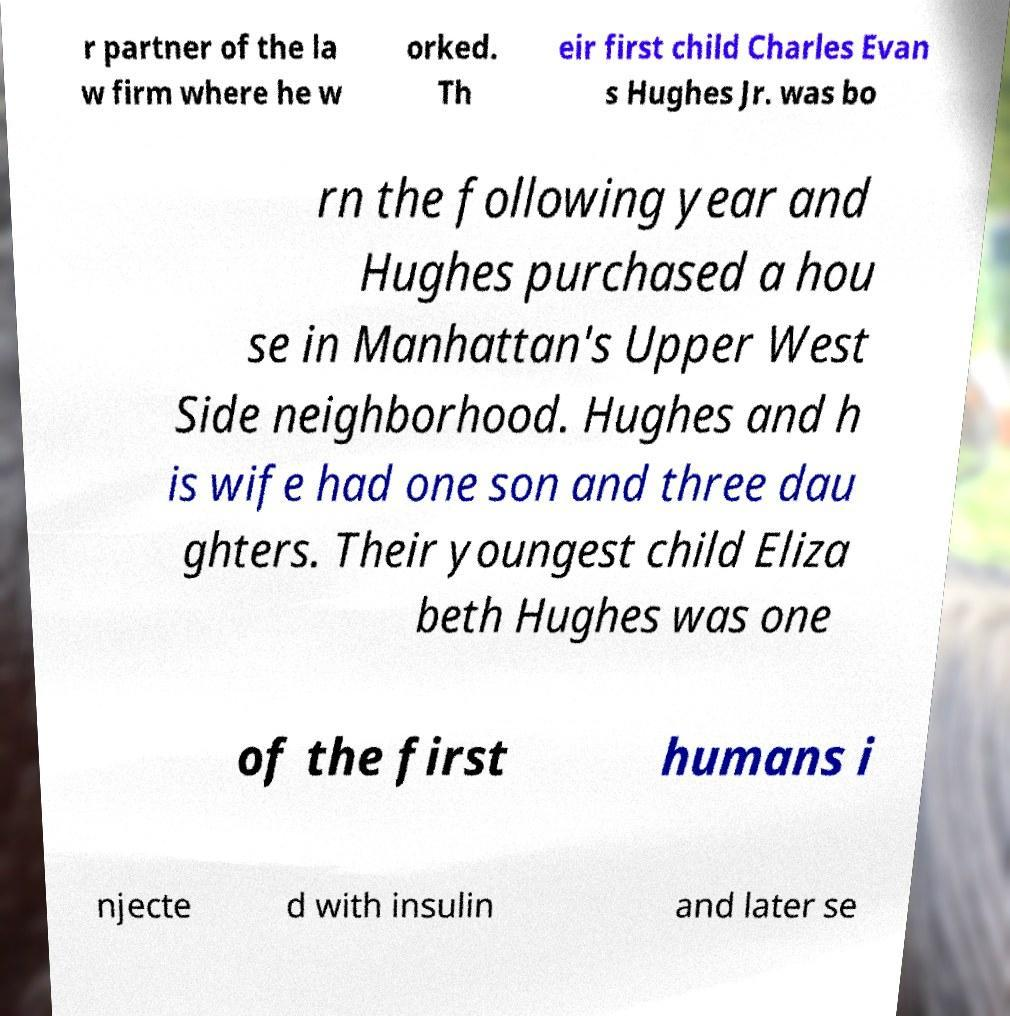Could you assist in decoding the text presented in this image and type it out clearly? r partner of the la w firm where he w orked. Th eir first child Charles Evan s Hughes Jr. was bo rn the following year and Hughes purchased a hou se in Manhattan's Upper West Side neighborhood. Hughes and h is wife had one son and three dau ghters. Their youngest child Eliza beth Hughes was one of the first humans i njecte d with insulin and later se 